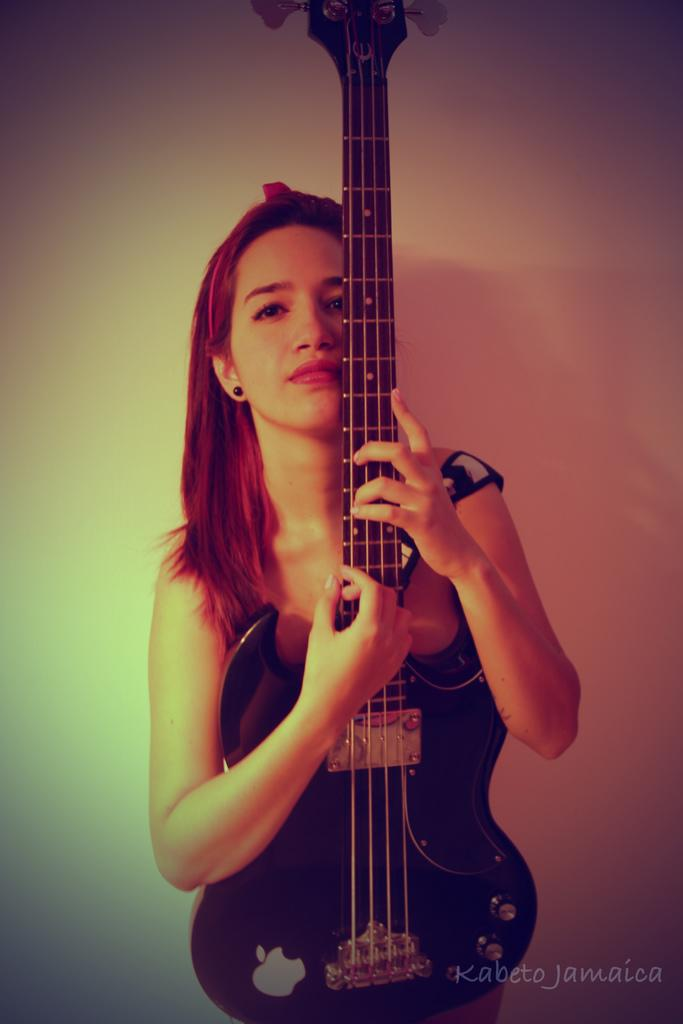What is the main subject of the image? The main subject of the image is a woman. What is the woman doing in the image? The woman is standing in the image. What object is the woman holding in the image? The woman is holding a guitar in the image. What type of hammer is the woman using in the image? There is no hammer present in the image; the woman is holding a guitar. Is the woman swimming in the image? No, the woman is not swimming in the image; she is standing and holding a guitar. 